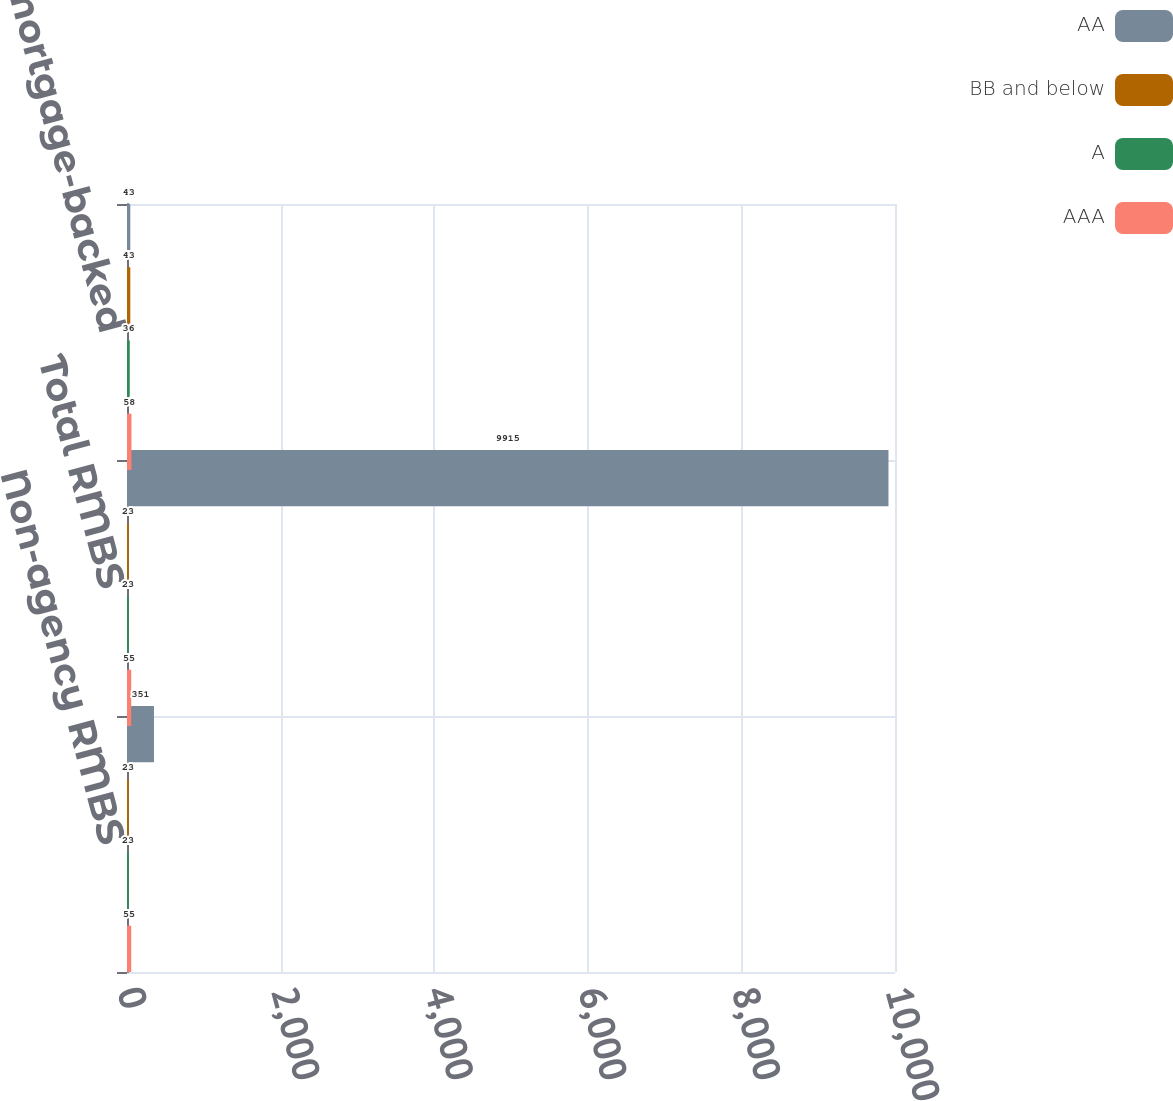Convert chart. <chart><loc_0><loc_0><loc_500><loc_500><stacked_bar_chart><ecel><fcel>Non-agency RMBS<fcel>Total RMBS<fcel>Total mortgage-backed<nl><fcel>AA<fcel>351<fcel>9915<fcel>43<nl><fcel>BB and below<fcel>23<fcel>23<fcel>43<nl><fcel>A<fcel>23<fcel>23<fcel>36<nl><fcel>AAA<fcel>55<fcel>55<fcel>58<nl></chart> 